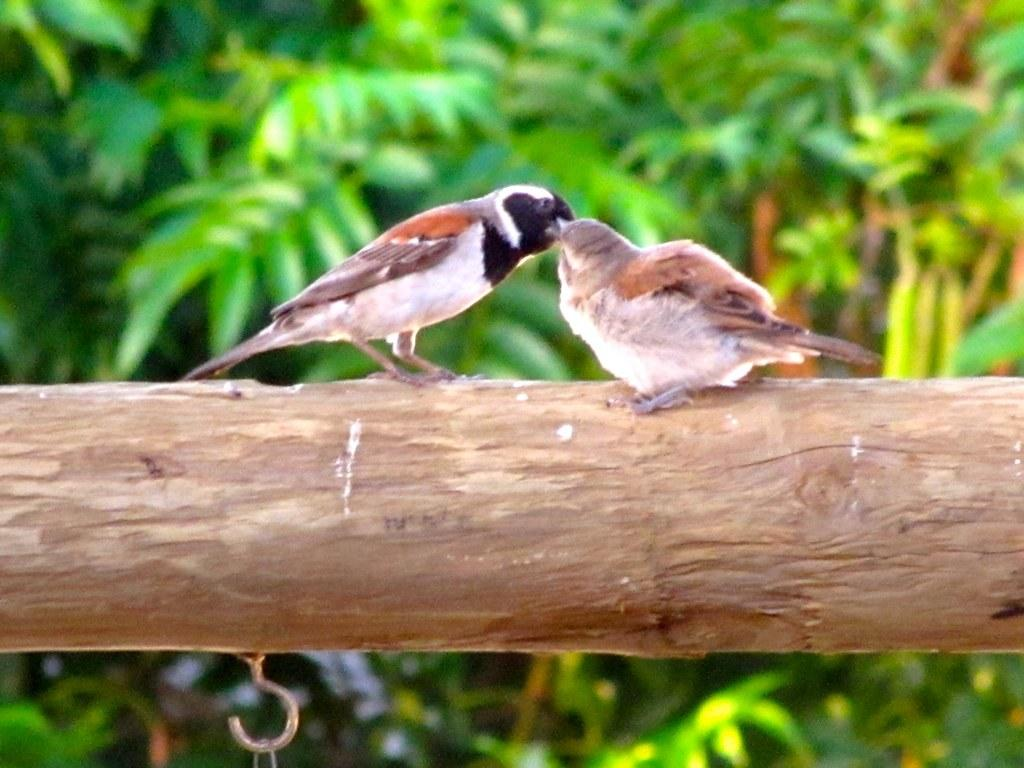What type of birds are in the image? There are two sparrows in the image. Where are the sparrows located? The sparrows are standing on a branch. What can be seen in the background of the image? There are leaves visible in the background of the image. How many toes does each sparrow have on its suit in the image? There are no suits present in the image, and sparrows do not wear clothing. Additionally, the number of toes on a sparrow's foot cannot be determined from the image. 